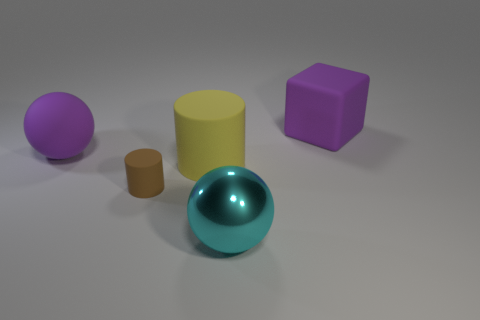Add 4 large purple blocks. How many objects exist? 9 Subtract all cylinders. How many objects are left? 3 Add 5 small purple metal cylinders. How many small purple metal cylinders exist? 5 Subtract 0 gray balls. How many objects are left? 5 Subtract all brown metal blocks. Subtract all large cylinders. How many objects are left? 4 Add 4 matte cubes. How many matte cubes are left? 5 